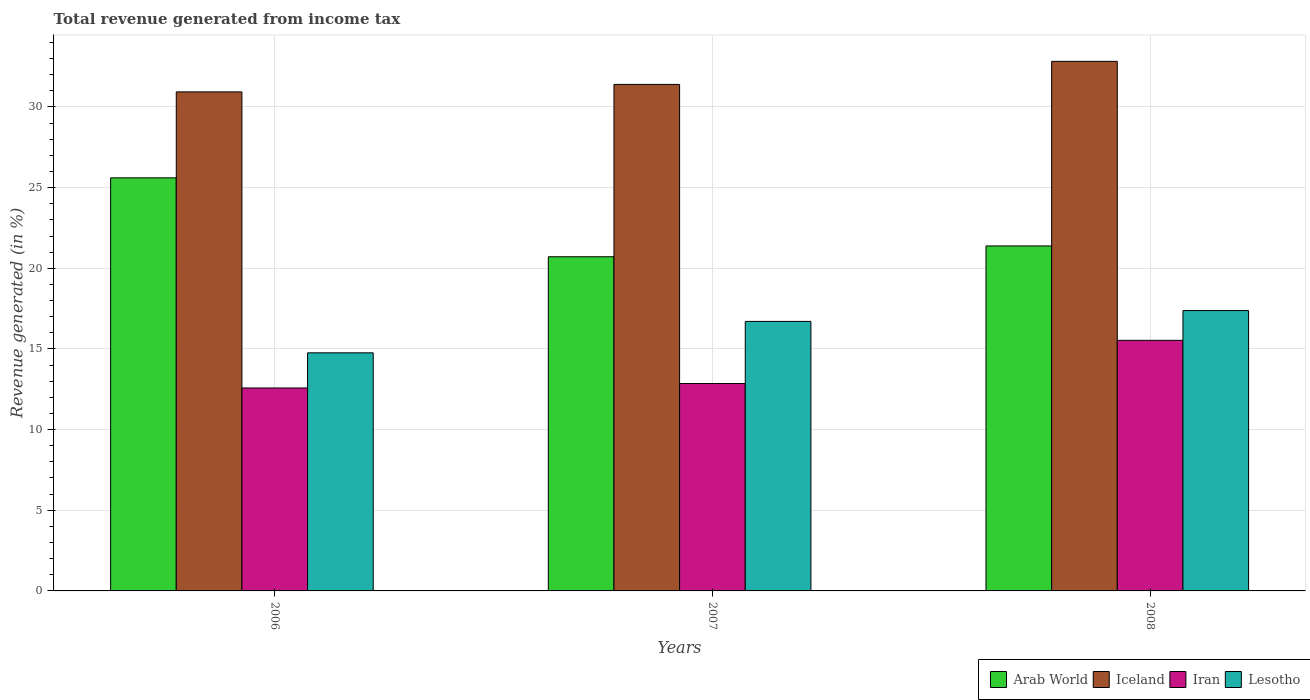How many different coloured bars are there?
Ensure brevity in your answer.  4. Are the number of bars on each tick of the X-axis equal?
Provide a short and direct response. Yes. How many bars are there on the 3rd tick from the left?
Provide a short and direct response. 4. What is the total revenue generated in Iceland in 2006?
Give a very brief answer. 30.93. Across all years, what is the maximum total revenue generated in Arab World?
Your response must be concise. 25.61. Across all years, what is the minimum total revenue generated in Lesotho?
Provide a short and direct response. 14.76. In which year was the total revenue generated in Arab World maximum?
Your answer should be compact. 2006. In which year was the total revenue generated in Arab World minimum?
Your answer should be very brief. 2007. What is the total total revenue generated in Lesotho in the graph?
Offer a very short reply. 48.85. What is the difference between the total revenue generated in Iceland in 2007 and that in 2008?
Provide a short and direct response. -1.43. What is the difference between the total revenue generated in Lesotho in 2008 and the total revenue generated in Arab World in 2006?
Offer a very short reply. -8.23. What is the average total revenue generated in Arab World per year?
Keep it short and to the point. 22.57. In the year 2007, what is the difference between the total revenue generated in Iran and total revenue generated in Arab World?
Keep it short and to the point. -7.86. In how many years, is the total revenue generated in Iran greater than 3 %?
Give a very brief answer. 3. What is the ratio of the total revenue generated in Arab World in 2007 to that in 2008?
Make the answer very short. 0.97. What is the difference between the highest and the second highest total revenue generated in Iceland?
Your answer should be compact. 1.43. What is the difference between the highest and the lowest total revenue generated in Iran?
Ensure brevity in your answer.  2.95. In how many years, is the total revenue generated in Iran greater than the average total revenue generated in Iran taken over all years?
Offer a very short reply. 1. Is the sum of the total revenue generated in Arab World in 2007 and 2008 greater than the maximum total revenue generated in Iceland across all years?
Offer a very short reply. Yes. Is it the case that in every year, the sum of the total revenue generated in Iran and total revenue generated in Lesotho is greater than the sum of total revenue generated in Iceland and total revenue generated in Arab World?
Keep it short and to the point. No. What does the 3rd bar from the left in 2008 represents?
Provide a succinct answer. Iran. What does the 1st bar from the right in 2008 represents?
Give a very brief answer. Lesotho. Is it the case that in every year, the sum of the total revenue generated in Iceland and total revenue generated in Iran is greater than the total revenue generated in Arab World?
Your response must be concise. Yes. How many bars are there?
Your answer should be very brief. 12. How many years are there in the graph?
Your answer should be very brief. 3. What is the difference between two consecutive major ticks on the Y-axis?
Provide a succinct answer. 5. Where does the legend appear in the graph?
Offer a terse response. Bottom right. How are the legend labels stacked?
Ensure brevity in your answer.  Horizontal. What is the title of the graph?
Your answer should be very brief. Total revenue generated from income tax. What is the label or title of the X-axis?
Your answer should be compact. Years. What is the label or title of the Y-axis?
Offer a terse response. Revenue generated (in %). What is the Revenue generated (in %) of Arab World in 2006?
Your response must be concise. 25.61. What is the Revenue generated (in %) of Iceland in 2006?
Ensure brevity in your answer.  30.93. What is the Revenue generated (in %) of Iran in 2006?
Your answer should be very brief. 12.58. What is the Revenue generated (in %) of Lesotho in 2006?
Offer a terse response. 14.76. What is the Revenue generated (in %) of Arab World in 2007?
Make the answer very short. 20.71. What is the Revenue generated (in %) of Iceland in 2007?
Your answer should be very brief. 31.4. What is the Revenue generated (in %) in Iran in 2007?
Ensure brevity in your answer.  12.86. What is the Revenue generated (in %) in Lesotho in 2007?
Keep it short and to the point. 16.71. What is the Revenue generated (in %) in Arab World in 2008?
Your response must be concise. 21.38. What is the Revenue generated (in %) in Iceland in 2008?
Your response must be concise. 32.83. What is the Revenue generated (in %) of Iran in 2008?
Keep it short and to the point. 15.53. What is the Revenue generated (in %) of Lesotho in 2008?
Offer a very short reply. 17.38. Across all years, what is the maximum Revenue generated (in %) in Arab World?
Keep it short and to the point. 25.61. Across all years, what is the maximum Revenue generated (in %) in Iceland?
Keep it short and to the point. 32.83. Across all years, what is the maximum Revenue generated (in %) in Iran?
Offer a very short reply. 15.53. Across all years, what is the maximum Revenue generated (in %) of Lesotho?
Ensure brevity in your answer.  17.38. Across all years, what is the minimum Revenue generated (in %) of Arab World?
Make the answer very short. 20.71. Across all years, what is the minimum Revenue generated (in %) in Iceland?
Give a very brief answer. 30.93. Across all years, what is the minimum Revenue generated (in %) in Iran?
Give a very brief answer. 12.58. Across all years, what is the minimum Revenue generated (in %) in Lesotho?
Make the answer very short. 14.76. What is the total Revenue generated (in %) of Arab World in the graph?
Ensure brevity in your answer.  67.7. What is the total Revenue generated (in %) of Iceland in the graph?
Give a very brief answer. 95.16. What is the total Revenue generated (in %) of Iran in the graph?
Keep it short and to the point. 40.97. What is the total Revenue generated (in %) of Lesotho in the graph?
Make the answer very short. 48.85. What is the difference between the Revenue generated (in %) of Arab World in 2006 and that in 2007?
Give a very brief answer. 4.89. What is the difference between the Revenue generated (in %) in Iceland in 2006 and that in 2007?
Provide a succinct answer. -0.46. What is the difference between the Revenue generated (in %) in Iran in 2006 and that in 2007?
Give a very brief answer. -0.27. What is the difference between the Revenue generated (in %) in Lesotho in 2006 and that in 2007?
Ensure brevity in your answer.  -1.95. What is the difference between the Revenue generated (in %) of Arab World in 2006 and that in 2008?
Offer a very short reply. 4.22. What is the difference between the Revenue generated (in %) in Iceland in 2006 and that in 2008?
Give a very brief answer. -1.89. What is the difference between the Revenue generated (in %) of Iran in 2006 and that in 2008?
Make the answer very short. -2.95. What is the difference between the Revenue generated (in %) in Lesotho in 2006 and that in 2008?
Offer a very short reply. -2.62. What is the difference between the Revenue generated (in %) in Arab World in 2007 and that in 2008?
Give a very brief answer. -0.67. What is the difference between the Revenue generated (in %) in Iceland in 2007 and that in 2008?
Your answer should be very brief. -1.43. What is the difference between the Revenue generated (in %) in Iran in 2007 and that in 2008?
Your response must be concise. -2.68. What is the difference between the Revenue generated (in %) in Lesotho in 2007 and that in 2008?
Ensure brevity in your answer.  -0.67. What is the difference between the Revenue generated (in %) of Arab World in 2006 and the Revenue generated (in %) of Iceland in 2007?
Your response must be concise. -5.79. What is the difference between the Revenue generated (in %) of Arab World in 2006 and the Revenue generated (in %) of Iran in 2007?
Ensure brevity in your answer.  12.75. What is the difference between the Revenue generated (in %) of Arab World in 2006 and the Revenue generated (in %) of Lesotho in 2007?
Your response must be concise. 8.9. What is the difference between the Revenue generated (in %) in Iceland in 2006 and the Revenue generated (in %) in Iran in 2007?
Provide a succinct answer. 18.08. What is the difference between the Revenue generated (in %) in Iceland in 2006 and the Revenue generated (in %) in Lesotho in 2007?
Give a very brief answer. 14.23. What is the difference between the Revenue generated (in %) in Iran in 2006 and the Revenue generated (in %) in Lesotho in 2007?
Your response must be concise. -4.13. What is the difference between the Revenue generated (in %) in Arab World in 2006 and the Revenue generated (in %) in Iceland in 2008?
Your response must be concise. -7.22. What is the difference between the Revenue generated (in %) of Arab World in 2006 and the Revenue generated (in %) of Iran in 2008?
Your answer should be very brief. 10.07. What is the difference between the Revenue generated (in %) of Arab World in 2006 and the Revenue generated (in %) of Lesotho in 2008?
Your response must be concise. 8.23. What is the difference between the Revenue generated (in %) in Iceland in 2006 and the Revenue generated (in %) in Iran in 2008?
Keep it short and to the point. 15.4. What is the difference between the Revenue generated (in %) of Iceland in 2006 and the Revenue generated (in %) of Lesotho in 2008?
Ensure brevity in your answer.  13.56. What is the difference between the Revenue generated (in %) of Iran in 2006 and the Revenue generated (in %) of Lesotho in 2008?
Provide a short and direct response. -4.8. What is the difference between the Revenue generated (in %) of Arab World in 2007 and the Revenue generated (in %) of Iceland in 2008?
Your answer should be very brief. -12.11. What is the difference between the Revenue generated (in %) of Arab World in 2007 and the Revenue generated (in %) of Iran in 2008?
Ensure brevity in your answer.  5.18. What is the difference between the Revenue generated (in %) of Arab World in 2007 and the Revenue generated (in %) of Lesotho in 2008?
Give a very brief answer. 3.34. What is the difference between the Revenue generated (in %) of Iceland in 2007 and the Revenue generated (in %) of Iran in 2008?
Give a very brief answer. 15.86. What is the difference between the Revenue generated (in %) of Iceland in 2007 and the Revenue generated (in %) of Lesotho in 2008?
Ensure brevity in your answer.  14.02. What is the difference between the Revenue generated (in %) of Iran in 2007 and the Revenue generated (in %) of Lesotho in 2008?
Give a very brief answer. -4.52. What is the average Revenue generated (in %) of Arab World per year?
Offer a terse response. 22.57. What is the average Revenue generated (in %) of Iceland per year?
Your response must be concise. 31.72. What is the average Revenue generated (in %) in Iran per year?
Ensure brevity in your answer.  13.66. What is the average Revenue generated (in %) of Lesotho per year?
Ensure brevity in your answer.  16.28. In the year 2006, what is the difference between the Revenue generated (in %) of Arab World and Revenue generated (in %) of Iceland?
Provide a short and direct response. -5.33. In the year 2006, what is the difference between the Revenue generated (in %) of Arab World and Revenue generated (in %) of Iran?
Give a very brief answer. 13.03. In the year 2006, what is the difference between the Revenue generated (in %) of Arab World and Revenue generated (in %) of Lesotho?
Your answer should be very brief. 10.85. In the year 2006, what is the difference between the Revenue generated (in %) in Iceland and Revenue generated (in %) in Iran?
Offer a terse response. 18.35. In the year 2006, what is the difference between the Revenue generated (in %) of Iceland and Revenue generated (in %) of Lesotho?
Make the answer very short. 16.18. In the year 2006, what is the difference between the Revenue generated (in %) in Iran and Revenue generated (in %) in Lesotho?
Offer a very short reply. -2.18. In the year 2007, what is the difference between the Revenue generated (in %) of Arab World and Revenue generated (in %) of Iceland?
Offer a very short reply. -10.68. In the year 2007, what is the difference between the Revenue generated (in %) of Arab World and Revenue generated (in %) of Iran?
Your answer should be compact. 7.86. In the year 2007, what is the difference between the Revenue generated (in %) in Arab World and Revenue generated (in %) in Lesotho?
Make the answer very short. 4.01. In the year 2007, what is the difference between the Revenue generated (in %) of Iceland and Revenue generated (in %) of Iran?
Your response must be concise. 18.54. In the year 2007, what is the difference between the Revenue generated (in %) of Iceland and Revenue generated (in %) of Lesotho?
Keep it short and to the point. 14.69. In the year 2007, what is the difference between the Revenue generated (in %) in Iran and Revenue generated (in %) in Lesotho?
Your response must be concise. -3.85. In the year 2008, what is the difference between the Revenue generated (in %) in Arab World and Revenue generated (in %) in Iceland?
Your response must be concise. -11.44. In the year 2008, what is the difference between the Revenue generated (in %) of Arab World and Revenue generated (in %) of Iran?
Offer a very short reply. 5.85. In the year 2008, what is the difference between the Revenue generated (in %) of Arab World and Revenue generated (in %) of Lesotho?
Provide a short and direct response. 4.01. In the year 2008, what is the difference between the Revenue generated (in %) of Iceland and Revenue generated (in %) of Iran?
Your response must be concise. 17.29. In the year 2008, what is the difference between the Revenue generated (in %) in Iceland and Revenue generated (in %) in Lesotho?
Offer a terse response. 15.45. In the year 2008, what is the difference between the Revenue generated (in %) of Iran and Revenue generated (in %) of Lesotho?
Keep it short and to the point. -1.85. What is the ratio of the Revenue generated (in %) of Arab World in 2006 to that in 2007?
Offer a terse response. 1.24. What is the ratio of the Revenue generated (in %) in Iceland in 2006 to that in 2007?
Your response must be concise. 0.99. What is the ratio of the Revenue generated (in %) of Iran in 2006 to that in 2007?
Make the answer very short. 0.98. What is the ratio of the Revenue generated (in %) in Lesotho in 2006 to that in 2007?
Your answer should be very brief. 0.88. What is the ratio of the Revenue generated (in %) of Arab World in 2006 to that in 2008?
Ensure brevity in your answer.  1.2. What is the ratio of the Revenue generated (in %) in Iceland in 2006 to that in 2008?
Make the answer very short. 0.94. What is the ratio of the Revenue generated (in %) of Iran in 2006 to that in 2008?
Your answer should be very brief. 0.81. What is the ratio of the Revenue generated (in %) in Lesotho in 2006 to that in 2008?
Your response must be concise. 0.85. What is the ratio of the Revenue generated (in %) in Arab World in 2007 to that in 2008?
Offer a terse response. 0.97. What is the ratio of the Revenue generated (in %) in Iceland in 2007 to that in 2008?
Your answer should be very brief. 0.96. What is the ratio of the Revenue generated (in %) of Iran in 2007 to that in 2008?
Offer a terse response. 0.83. What is the ratio of the Revenue generated (in %) of Lesotho in 2007 to that in 2008?
Your answer should be compact. 0.96. What is the difference between the highest and the second highest Revenue generated (in %) in Arab World?
Offer a terse response. 4.22. What is the difference between the highest and the second highest Revenue generated (in %) in Iceland?
Provide a short and direct response. 1.43. What is the difference between the highest and the second highest Revenue generated (in %) of Iran?
Offer a terse response. 2.68. What is the difference between the highest and the second highest Revenue generated (in %) of Lesotho?
Offer a very short reply. 0.67. What is the difference between the highest and the lowest Revenue generated (in %) of Arab World?
Your response must be concise. 4.89. What is the difference between the highest and the lowest Revenue generated (in %) of Iceland?
Keep it short and to the point. 1.89. What is the difference between the highest and the lowest Revenue generated (in %) in Iran?
Provide a succinct answer. 2.95. What is the difference between the highest and the lowest Revenue generated (in %) in Lesotho?
Provide a short and direct response. 2.62. 